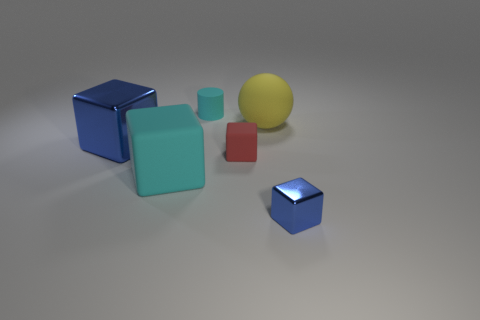Add 1 cyan matte objects. How many objects exist? 7 Subtract all balls. How many objects are left? 5 Add 3 red rubber cubes. How many red rubber cubes exist? 4 Subtract 0 cyan spheres. How many objects are left? 6 Subtract all blocks. Subtract all big metallic blocks. How many objects are left? 1 Add 4 big spheres. How many big spheres are left? 5 